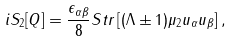<formula> <loc_0><loc_0><loc_500><loc_500>i S _ { 2 } [ Q ] = \frac { \epsilon _ { \alpha \beta } } { 8 } S t r \left [ ( \Lambda \pm 1 ) \mu _ { 2 } u _ { \alpha } u _ { \beta } \right ] ,</formula> 